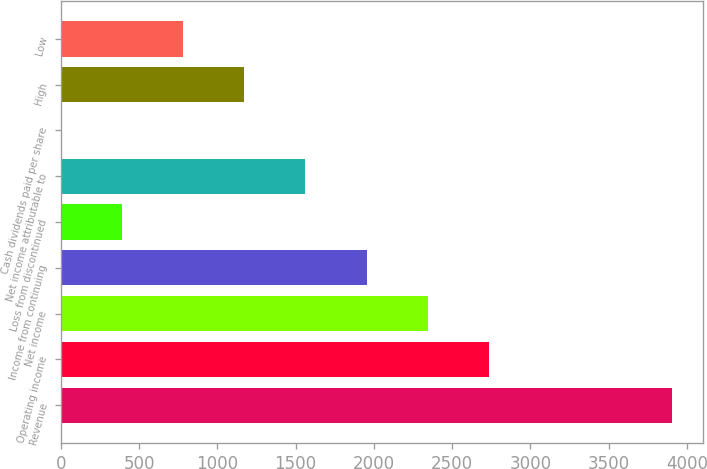<chart> <loc_0><loc_0><loc_500><loc_500><bar_chart><fcel>Revenue<fcel>Operating income<fcel>Net income<fcel>Income from continuing<fcel>Loss from discontinued<fcel>Net income attributable to<fcel>Cash dividends paid per share<fcel>High<fcel>Low<nl><fcel>3907<fcel>2734.92<fcel>2344.23<fcel>1953.54<fcel>390.78<fcel>1562.85<fcel>0.09<fcel>1172.16<fcel>781.47<nl></chart> 